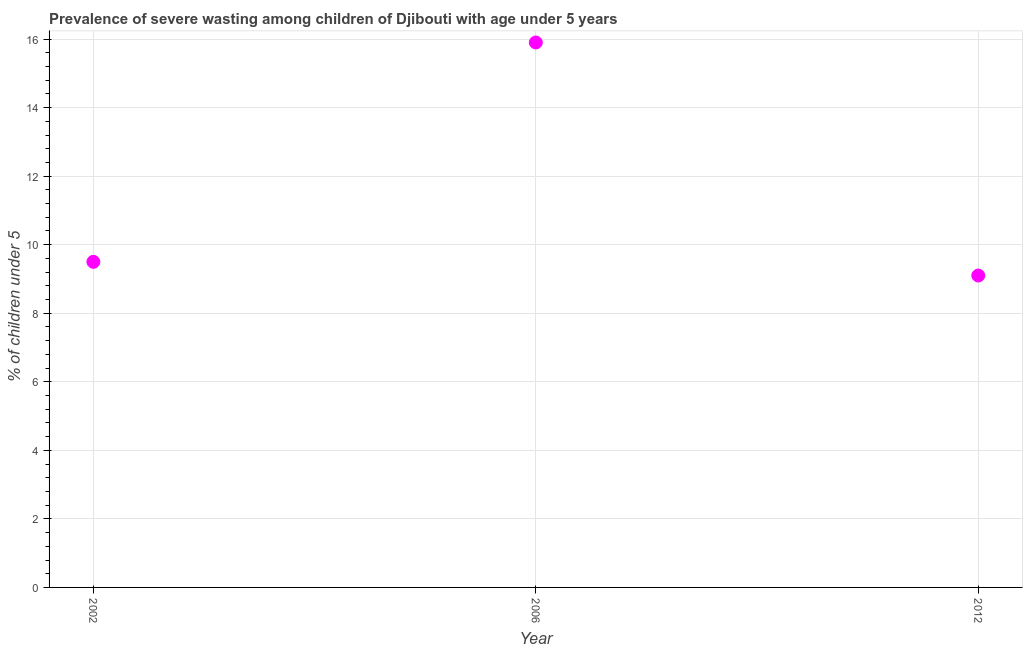What is the prevalence of severe wasting in 2012?
Make the answer very short. 9.1. Across all years, what is the maximum prevalence of severe wasting?
Offer a terse response. 15.9. Across all years, what is the minimum prevalence of severe wasting?
Your answer should be very brief. 9.1. In which year was the prevalence of severe wasting maximum?
Your response must be concise. 2006. What is the sum of the prevalence of severe wasting?
Keep it short and to the point. 34.5. What is the difference between the prevalence of severe wasting in 2002 and 2012?
Keep it short and to the point. 0.4. What is the average prevalence of severe wasting per year?
Your answer should be compact. 11.5. What is the median prevalence of severe wasting?
Provide a succinct answer. 9.5. Do a majority of the years between 2006 and 2012 (inclusive) have prevalence of severe wasting greater than 5.6 %?
Your response must be concise. Yes. What is the ratio of the prevalence of severe wasting in 2002 to that in 2012?
Give a very brief answer. 1.04. What is the difference between the highest and the second highest prevalence of severe wasting?
Give a very brief answer. 6.4. What is the difference between the highest and the lowest prevalence of severe wasting?
Ensure brevity in your answer.  6.8. How many dotlines are there?
Make the answer very short. 1. How many years are there in the graph?
Your answer should be very brief. 3. Does the graph contain any zero values?
Provide a short and direct response. No. Does the graph contain grids?
Ensure brevity in your answer.  Yes. What is the title of the graph?
Provide a short and direct response. Prevalence of severe wasting among children of Djibouti with age under 5 years. What is the label or title of the Y-axis?
Make the answer very short.  % of children under 5. What is the  % of children under 5 in 2002?
Offer a very short reply. 9.5. What is the  % of children under 5 in 2006?
Your answer should be very brief. 15.9. What is the  % of children under 5 in 2012?
Ensure brevity in your answer.  9.1. What is the difference between the  % of children under 5 in 2002 and 2006?
Ensure brevity in your answer.  -6.4. What is the difference between the  % of children under 5 in 2006 and 2012?
Provide a succinct answer. 6.8. What is the ratio of the  % of children under 5 in 2002 to that in 2006?
Keep it short and to the point. 0.6. What is the ratio of the  % of children under 5 in 2002 to that in 2012?
Your answer should be compact. 1.04. What is the ratio of the  % of children under 5 in 2006 to that in 2012?
Offer a very short reply. 1.75. 